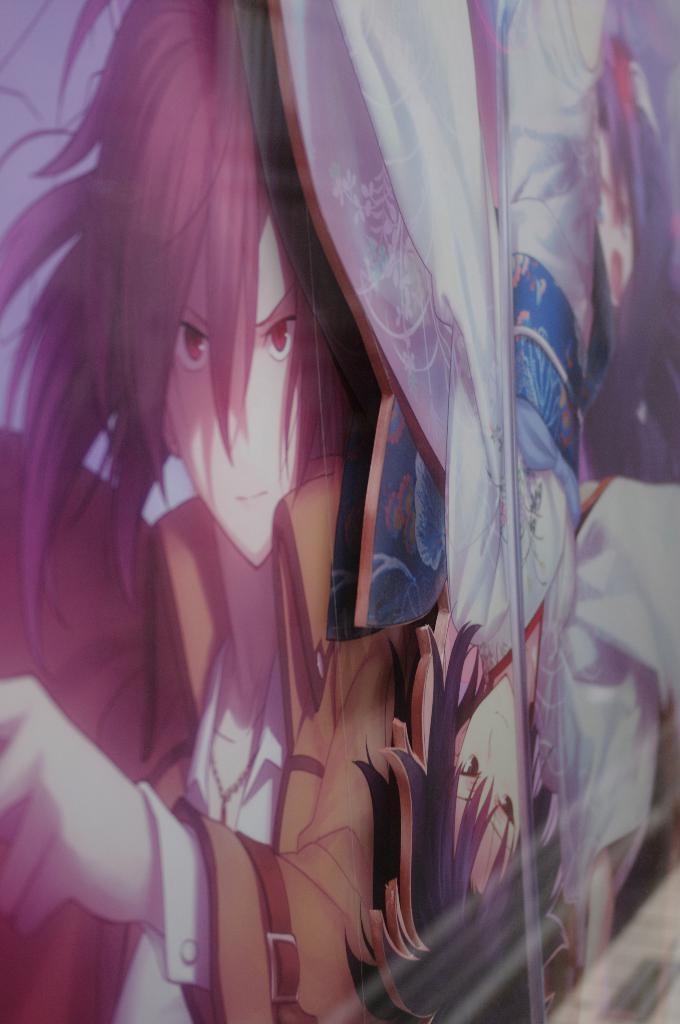Could you give a brief overview of what you see in this image? In this picture we can see the glass and cartoon image of two people. 